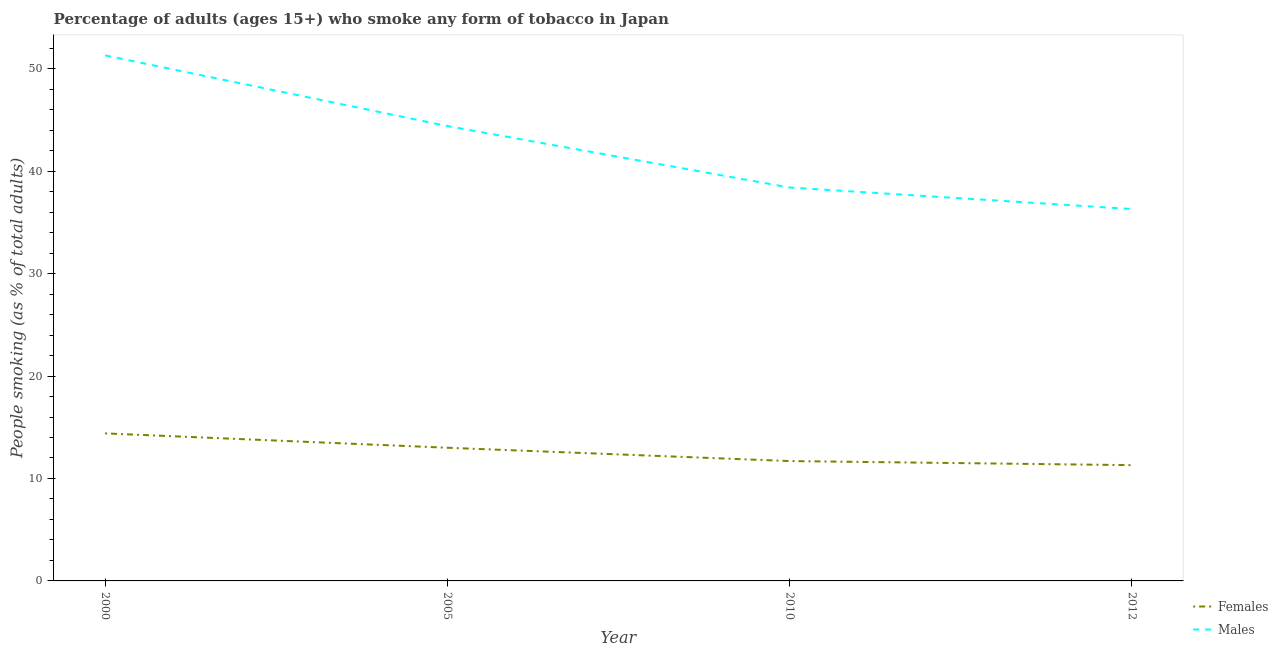How many different coloured lines are there?
Ensure brevity in your answer.  2. Does the line corresponding to percentage of males who smoke intersect with the line corresponding to percentage of females who smoke?
Offer a terse response. No. What is the percentage of males who smoke in 2010?
Offer a terse response. 38.4. Across all years, what is the maximum percentage of males who smoke?
Provide a short and direct response. 51.3. Across all years, what is the minimum percentage of males who smoke?
Your answer should be very brief. 36.3. In which year was the percentage of males who smoke maximum?
Make the answer very short. 2000. What is the total percentage of females who smoke in the graph?
Give a very brief answer. 50.4. What is the difference between the percentage of males who smoke in 2012 and the percentage of females who smoke in 2000?
Make the answer very short. 21.9. What is the average percentage of females who smoke per year?
Make the answer very short. 12.6. In the year 2005, what is the difference between the percentage of males who smoke and percentage of females who smoke?
Provide a short and direct response. 31.4. In how many years, is the percentage of males who smoke greater than 30 %?
Offer a very short reply. 4. What is the ratio of the percentage of males who smoke in 2010 to that in 2012?
Your answer should be compact. 1.06. Is the percentage of males who smoke in 2005 less than that in 2010?
Keep it short and to the point. No. Is the difference between the percentage of females who smoke in 2005 and 2010 greater than the difference between the percentage of males who smoke in 2005 and 2010?
Ensure brevity in your answer.  No. What is the difference between the highest and the second highest percentage of females who smoke?
Your answer should be very brief. 1.4. In how many years, is the percentage of females who smoke greater than the average percentage of females who smoke taken over all years?
Offer a terse response. 2. Is the percentage of females who smoke strictly greater than the percentage of males who smoke over the years?
Make the answer very short. No. Is the percentage of females who smoke strictly less than the percentage of males who smoke over the years?
Keep it short and to the point. Yes. How many lines are there?
Your answer should be compact. 2. How many years are there in the graph?
Provide a succinct answer. 4. What is the difference between two consecutive major ticks on the Y-axis?
Provide a succinct answer. 10. Are the values on the major ticks of Y-axis written in scientific E-notation?
Ensure brevity in your answer.  No. Does the graph contain any zero values?
Give a very brief answer. No. Does the graph contain grids?
Give a very brief answer. No. Where does the legend appear in the graph?
Give a very brief answer. Bottom right. How are the legend labels stacked?
Offer a very short reply. Vertical. What is the title of the graph?
Give a very brief answer. Percentage of adults (ages 15+) who smoke any form of tobacco in Japan. Does "GDP per capita" appear as one of the legend labels in the graph?
Ensure brevity in your answer.  No. What is the label or title of the Y-axis?
Provide a succinct answer. People smoking (as % of total adults). What is the People smoking (as % of total adults) of Males in 2000?
Keep it short and to the point. 51.3. What is the People smoking (as % of total adults) of Females in 2005?
Your response must be concise. 13. What is the People smoking (as % of total adults) in Males in 2005?
Ensure brevity in your answer.  44.4. What is the People smoking (as % of total adults) in Males in 2010?
Ensure brevity in your answer.  38.4. What is the People smoking (as % of total adults) in Males in 2012?
Offer a terse response. 36.3. Across all years, what is the maximum People smoking (as % of total adults) of Females?
Provide a short and direct response. 14.4. Across all years, what is the maximum People smoking (as % of total adults) of Males?
Make the answer very short. 51.3. Across all years, what is the minimum People smoking (as % of total adults) in Males?
Provide a short and direct response. 36.3. What is the total People smoking (as % of total adults) of Females in the graph?
Keep it short and to the point. 50.4. What is the total People smoking (as % of total adults) of Males in the graph?
Your answer should be compact. 170.4. What is the difference between the People smoking (as % of total adults) in Females in 2000 and that in 2010?
Give a very brief answer. 2.7. What is the difference between the People smoking (as % of total adults) in Males in 2000 and that in 2010?
Provide a short and direct response. 12.9. What is the difference between the People smoking (as % of total adults) of Males in 2000 and that in 2012?
Offer a terse response. 15. What is the difference between the People smoking (as % of total adults) in Females in 2005 and that in 2010?
Your response must be concise. 1.3. What is the difference between the People smoking (as % of total adults) in Females in 2010 and that in 2012?
Provide a succinct answer. 0.4. What is the difference between the People smoking (as % of total adults) of Females in 2000 and the People smoking (as % of total adults) of Males in 2005?
Your answer should be very brief. -30. What is the difference between the People smoking (as % of total adults) in Females in 2000 and the People smoking (as % of total adults) in Males in 2010?
Keep it short and to the point. -24. What is the difference between the People smoking (as % of total adults) in Females in 2000 and the People smoking (as % of total adults) in Males in 2012?
Provide a short and direct response. -21.9. What is the difference between the People smoking (as % of total adults) of Females in 2005 and the People smoking (as % of total adults) of Males in 2010?
Your answer should be compact. -25.4. What is the difference between the People smoking (as % of total adults) in Females in 2005 and the People smoking (as % of total adults) in Males in 2012?
Provide a succinct answer. -23.3. What is the difference between the People smoking (as % of total adults) of Females in 2010 and the People smoking (as % of total adults) of Males in 2012?
Offer a terse response. -24.6. What is the average People smoking (as % of total adults) in Females per year?
Provide a short and direct response. 12.6. What is the average People smoking (as % of total adults) of Males per year?
Offer a terse response. 42.6. In the year 2000, what is the difference between the People smoking (as % of total adults) in Females and People smoking (as % of total adults) in Males?
Make the answer very short. -36.9. In the year 2005, what is the difference between the People smoking (as % of total adults) in Females and People smoking (as % of total adults) in Males?
Provide a succinct answer. -31.4. In the year 2010, what is the difference between the People smoking (as % of total adults) of Females and People smoking (as % of total adults) of Males?
Your response must be concise. -26.7. What is the ratio of the People smoking (as % of total adults) of Females in 2000 to that in 2005?
Offer a terse response. 1.11. What is the ratio of the People smoking (as % of total adults) of Males in 2000 to that in 2005?
Your answer should be very brief. 1.16. What is the ratio of the People smoking (as % of total adults) in Females in 2000 to that in 2010?
Provide a succinct answer. 1.23. What is the ratio of the People smoking (as % of total adults) of Males in 2000 to that in 2010?
Make the answer very short. 1.34. What is the ratio of the People smoking (as % of total adults) in Females in 2000 to that in 2012?
Provide a short and direct response. 1.27. What is the ratio of the People smoking (as % of total adults) of Males in 2000 to that in 2012?
Keep it short and to the point. 1.41. What is the ratio of the People smoking (as % of total adults) of Females in 2005 to that in 2010?
Make the answer very short. 1.11. What is the ratio of the People smoking (as % of total adults) of Males in 2005 to that in 2010?
Your answer should be compact. 1.16. What is the ratio of the People smoking (as % of total adults) in Females in 2005 to that in 2012?
Your response must be concise. 1.15. What is the ratio of the People smoking (as % of total adults) in Males in 2005 to that in 2012?
Give a very brief answer. 1.22. What is the ratio of the People smoking (as % of total adults) in Females in 2010 to that in 2012?
Give a very brief answer. 1.04. What is the ratio of the People smoking (as % of total adults) in Males in 2010 to that in 2012?
Your answer should be compact. 1.06. What is the difference between the highest and the second highest People smoking (as % of total adults) of Males?
Your answer should be very brief. 6.9. What is the difference between the highest and the lowest People smoking (as % of total adults) in Males?
Ensure brevity in your answer.  15. 